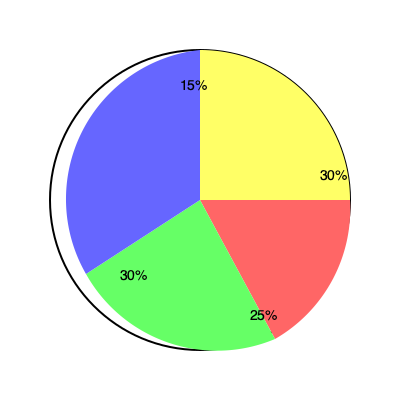Given your expertise in stock picking, you've been asked to analyze a friend's portfolio diversification. The pie chart shows their current allocation: 30% in tech stocks, 25% in energy stocks, 30% in financial stocks, and 15% in consumer goods stocks. If you recommend reducing the tech sector exposure by half and redistributing it equally among the other sectors, what would be the new percentage allocation for the financial sector? To solve this problem, let's follow these steps:

1. Identify the current allocation:
   - Tech: 30%
   - Energy: 25%
   - Financial: 30%
   - Consumer Goods: 15%

2. Calculate the amount to be redistributed from tech:
   $30\% \div 2 = 15\%$

3. Determine how much each remaining sector will receive:
   $15\% \div 3 = 5\%$ (since we're distributing equally among 3 sectors)

4. Calculate the new allocation for each sector:
   - Tech: $30\% - 15\% = 15\%$
   - Energy: $25\% + 5\% = 30\%$
   - Financial: $30\% + 5\% = 35\%$
   - Consumer Goods: $15\% + 5\% = 20\%$

5. Verify that the total still equals 100%:
   $15\% + 30\% + 35\% + 20\% = 100\%$

The new percentage allocation for the financial sector is 35%.
Answer: 35% 